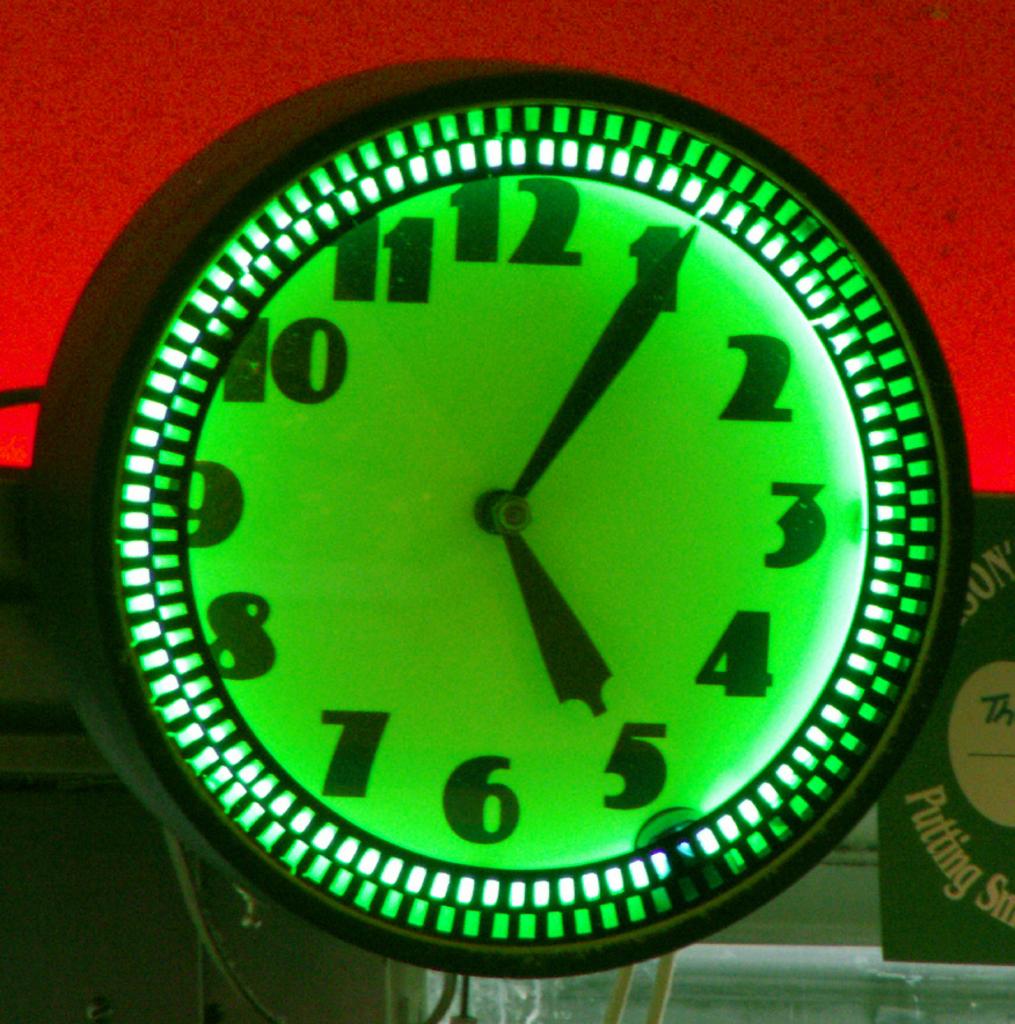What time is shown by this green clock?
Give a very brief answer. 5:05. Which number is the minute hand closest to?
Offer a very short reply. 1. 